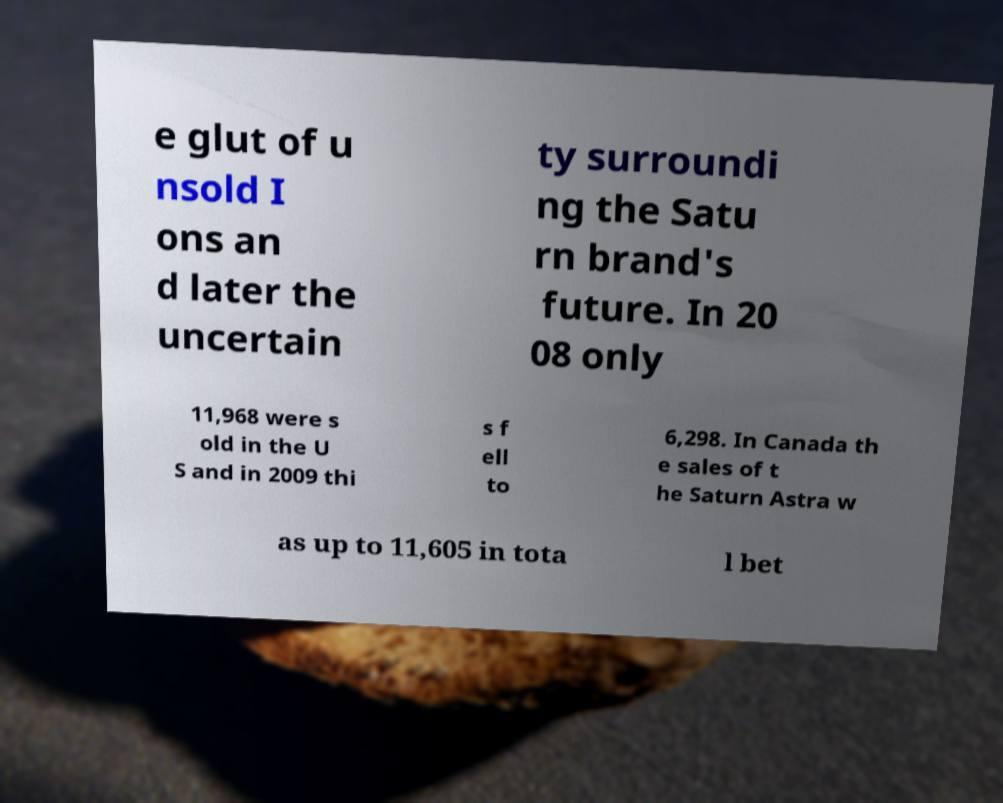Can you accurately transcribe the text from the provided image for me? e glut of u nsold I ons an d later the uncertain ty surroundi ng the Satu rn brand's future. In 20 08 only 11,968 were s old in the U S and in 2009 thi s f ell to 6,298. In Canada th e sales of t he Saturn Astra w as up to 11,605 in tota l bet 